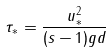Convert formula to latex. <formula><loc_0><loc_0><loc_500><loc_500>\tau _ { * } = \frac { u _ { * } ^ { 2 } } { ( s - 1 ) g d }</formula> 